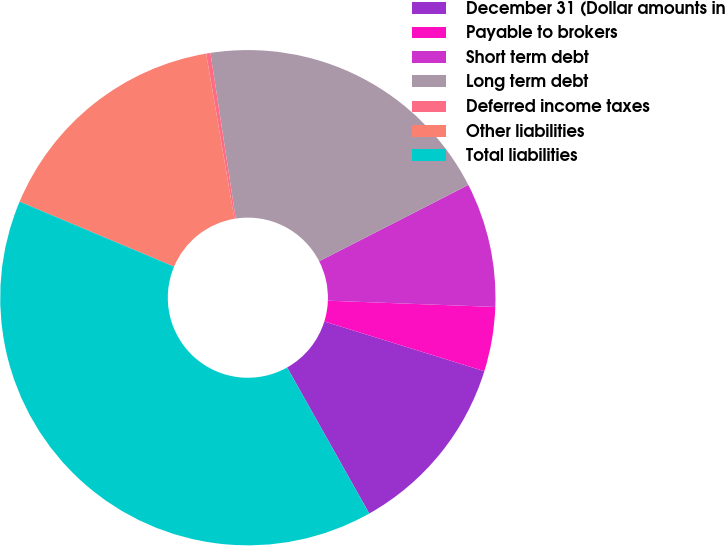Convert chart to OTSL. <chart><loc_0><loc_0><loc_500><loc_500><pie_chart><fcel>December 31 (Dollar amounts in<fcel>Payable to brokers<fcel>Short term debt<fcel>Long term debt<fcel>Deferred income taxes<fcel>Other liabilities<fcel>Total liabilities<nl><fcel>12.05%<fcel>4.2%<fcel>8.12%<fcel>19.89%<fcel>0.28%<fcel>15.97%<fcel>39.49%<nl></chart> 